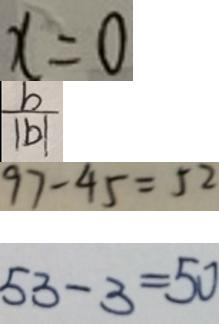<formula> <loc_0><loc_0><loc_500><loc_500>x = 0 
 \frac { b } { \vert b \vert } 
 9 7 - 4 5 = 5 2 
 5 3 - 3 = 5 0</formula> 